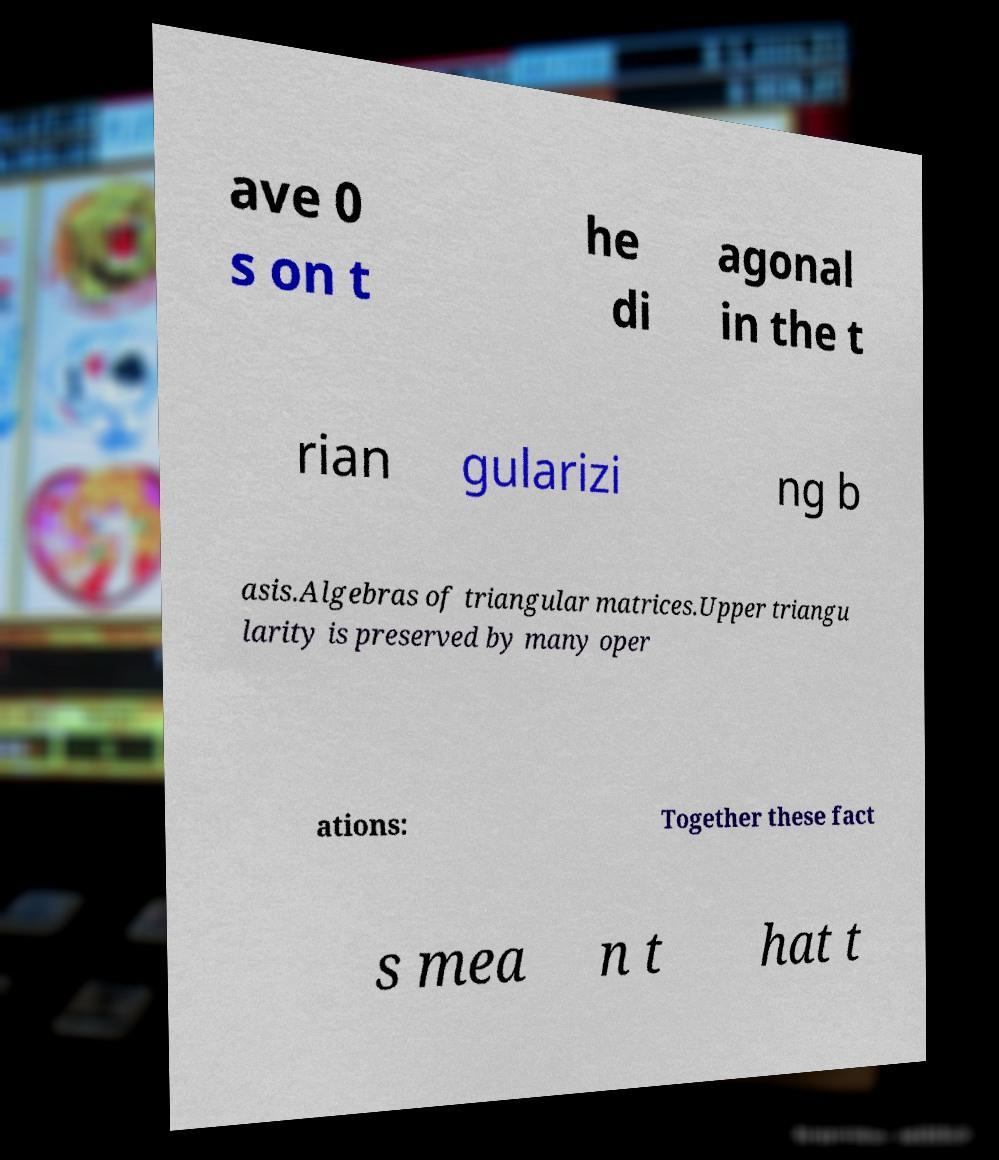Can you accurately transcribe the text from the provided image for me? ave 0 s on t he di agonal in the t rian gularizi ng b asis.Algebras of triangular matrices.Upper triangu larity is preserved by many oper ations: Together these fact s mea n t hat t 